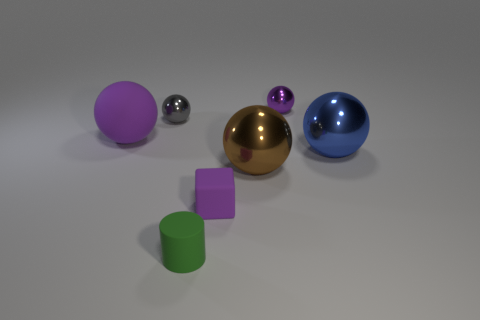Subtract 1 spheres. How many spheres are left? 4 Subtract all blue metallic spheres. How many spheres are left? 4 Add 1 small purple blocks. How many objects exist? 8 Subtract all purple spheres. How many spheres are left? 3 Subtract all cylinders. How many objects are left? 6 Subtract all cyan spheres. Subtract all red cubes. How many spheres are left? 5 Subtract all yellow balls. How many cyan cylinders are left? 0 Subtract all purple balls. Subtract all purple objects. How many objects are left? 2 Add 6 gray shiny spheres. How many gray shiny spheres are left? 7 Add 2 cylinders. How many cylinders exist? 3 